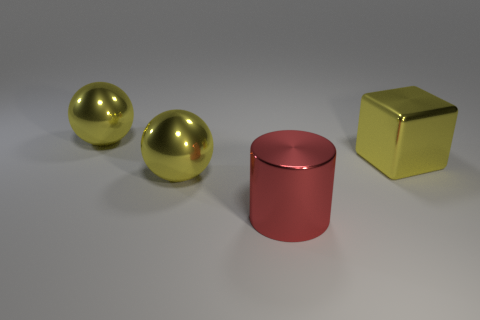Subtract all purple cubes. How many blue cylinders are left? 0 Subtract 0 brown balls. How many objects are left? 4 How many yellow spheres must be subtracted to get 1 yellow spheres? 1 Subtract all cylinders. How many objects are left? 3 Subtract 1 blocks. How many blocks are left? 0 Subtract all blue spheres. Subtract all brown cubes. How many spheres are left? 2 Subtract all small purple metallic cubes. Subtract all yellow spheres. How many objects are left? 2 Add 4 metallic things. How many metallic things are left? 8 Add 2 red metallic cylinders. How many red metallic cylinders exist? 3 Add 1 large gray metal cubes. How many objects exist? 5 